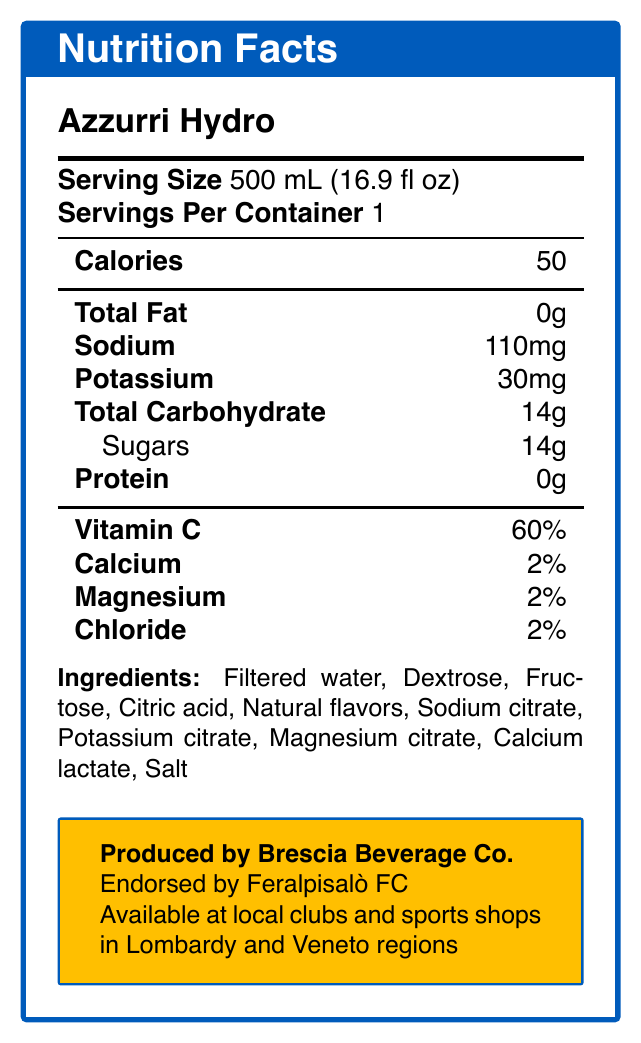What is the serving size of Azzurri Hydro? The serving size is mentioned in the first section of the nutrition facts label.
Answer: 500 mL (16.9 fl oz) How many calories are in one serving of Azzurri Hydro? The calories in one serving are listed as 50 in the nutrition facts label.
Answer: 50 What percentage of Vitamin C does Azzurri Hydro provide? The percentage of Vitamin C is clearly specified as 60%.
Answer: 60% What is the sodium content in a serving of Azzurri Hydro? The sodium content is listed in the nutrition facts as 110mg.
Answer: 110mg What is the primary target audience for Azzurri Hydro? The target audience is stated as Serie C and Serie D footballers in the additional information section.
Answer: Serie C and Serie D footballers Which football club endorses Azzurri Hydro? A. AC Milan B. Feralpisalò FC C. Juventus D. Brescia Calcio It is mentioned in the additional info box that Azzurri Hydro is endorsed by Feralpisalò FC.
Answer: B What is the product name of the sports hydration drink? A. Azzurri Power B. Azzurri Hydro C. Azzurri Fit D. Azzurri Sport The product name is listed at the top of the document as Azzurri Hydro.
Answer: B Does Azzurri Hydro contain any protein? The protein content is listed as 0g in the nutrition facts label.
Answer: No Is Azzurri Hydro suitable for rapid hydration? One of the key benefits listed is rapid hydration.
Answer: Yes Describe the main idea of the document. The document outlines the key nutritional components, target audience, benefits, and availability of the Azzurri Hydro sports drink.
Answer: The document is a Nutrition Facts Label for a sports hydration drink named Azzurri Hydro, detailing its nutritional composition, target audience, main benefits, and availability. The drink is endorsed by Feralpisalò FC and produced by Brescia Beverage Co., intended primarily for Serie C and Serie D footballers, emphasizing quick hydration and electrolyte replenishment. How much magnesium does Azzurri Hydro contain per serving? The magnesium content per serving is listed as 2%.
Answer: 2% What are the main benefits of Azzurri Hydro according to the document? These benefits are explicitly stated in the additional information section.
Answer: Rapid hydration, Electrolyte replenishment, Energy boost for 90-minute matches Which minerals in Azzurri Hydro contribute to electrolyte replenishment? A. Calcium, Sodium, Potassium, Magnesium B. Iron, Sodium, Chloride, Magnesium C. Sodium, Calcium, Magnesium, Chloride D. Calcium, Potassium, Magnesium, Chloride Based on the ingredients and listed minerals, Calcium, Sodium, Potassium, and Magnesium are relevant for electrolyte replenishment.
Answer: A What region is Azzurri Hydro produced in? The origin of production is specified as Brescia, Lombardy.
Answer: Brescia, Lombardy What flavors does Azzurri Hydro contain? The document lists "Natural flavors" but does not specify any particular flavors.
Answer: Not enough information Is Azzurri Hydro available outside Lombardy and Veneto regions? The document only states availability in local clubs and sports shops in Lombardy and Veneto regions; it does not provide information about availability outside these regions.
Answer: Not enough information 